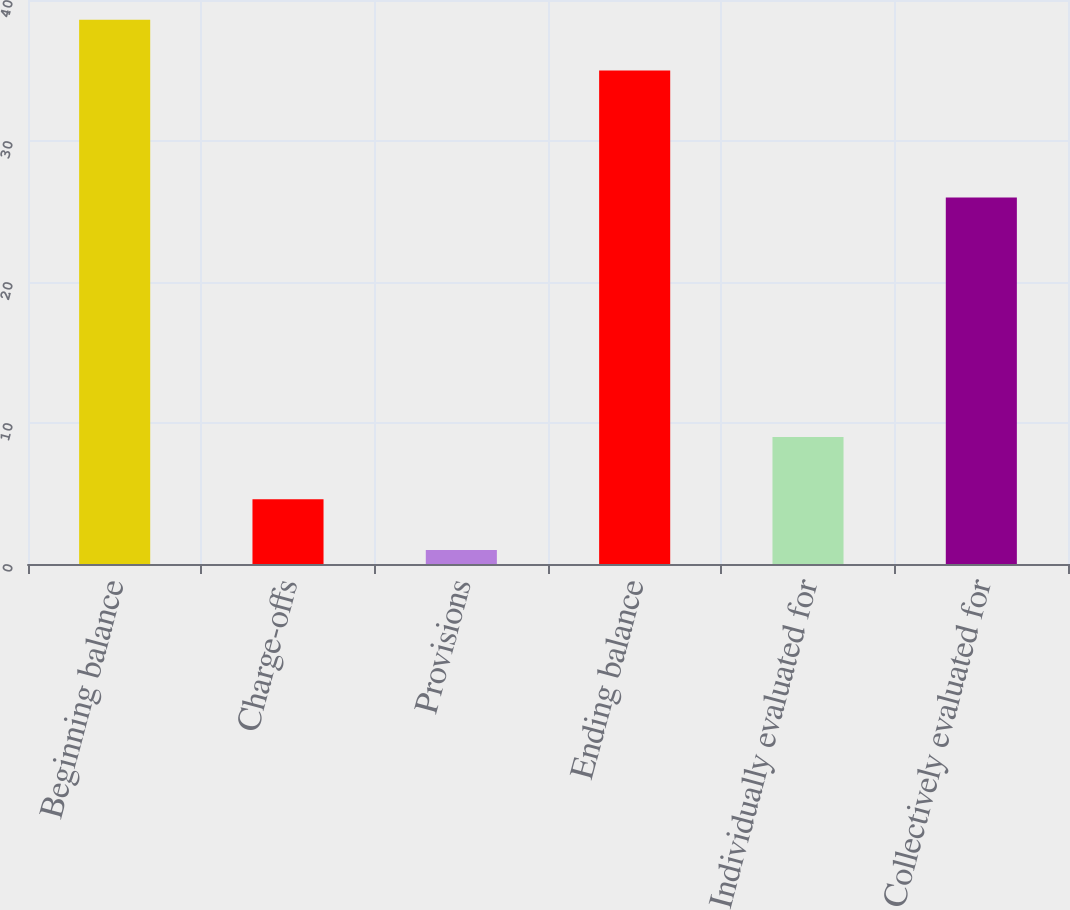<chart> <loc_0><loc_0><loc_500><loc_500><bar_chart><fcel>Beginning balance<fcel>Charge-offs<fcel>Provisions<fcel>Ending balance<fcel>Individually evaluated for<fcel>Collectively evaluated for<nl><fcel>38.6<fcel>4.6<fcel>1<fcel>35<fcel>9<fcel>26<nl></chart> 